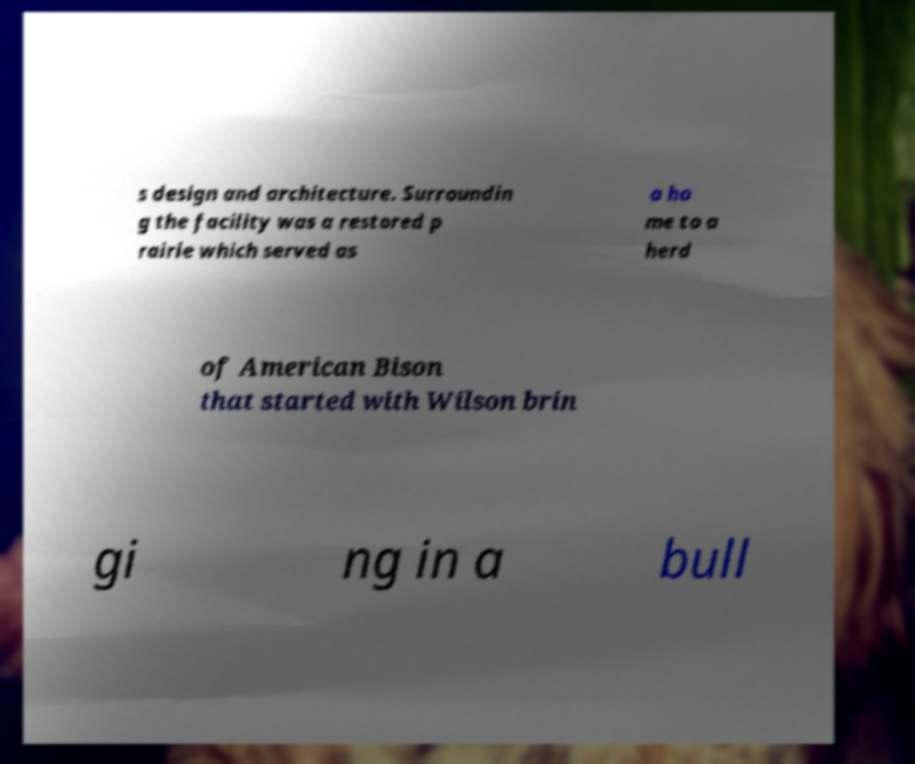There's text embedded in this image that I need extracted. Can you transcribe it verbatim? s design and architecture. Surroundin g the facility was a restored p rairie which served as a ho me to a herd of American Bison that started with Wilson brin gi ng in a bull 